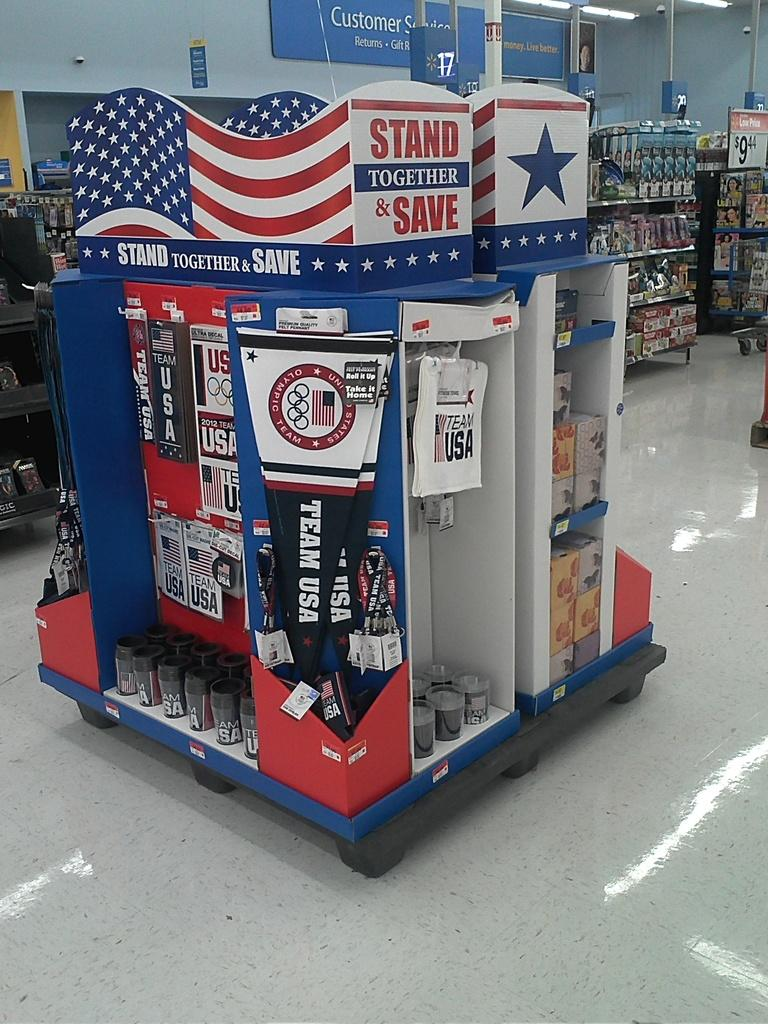<image>
Provide a brief description of the given image. A stand in a store which says "Stand Together & Save" 